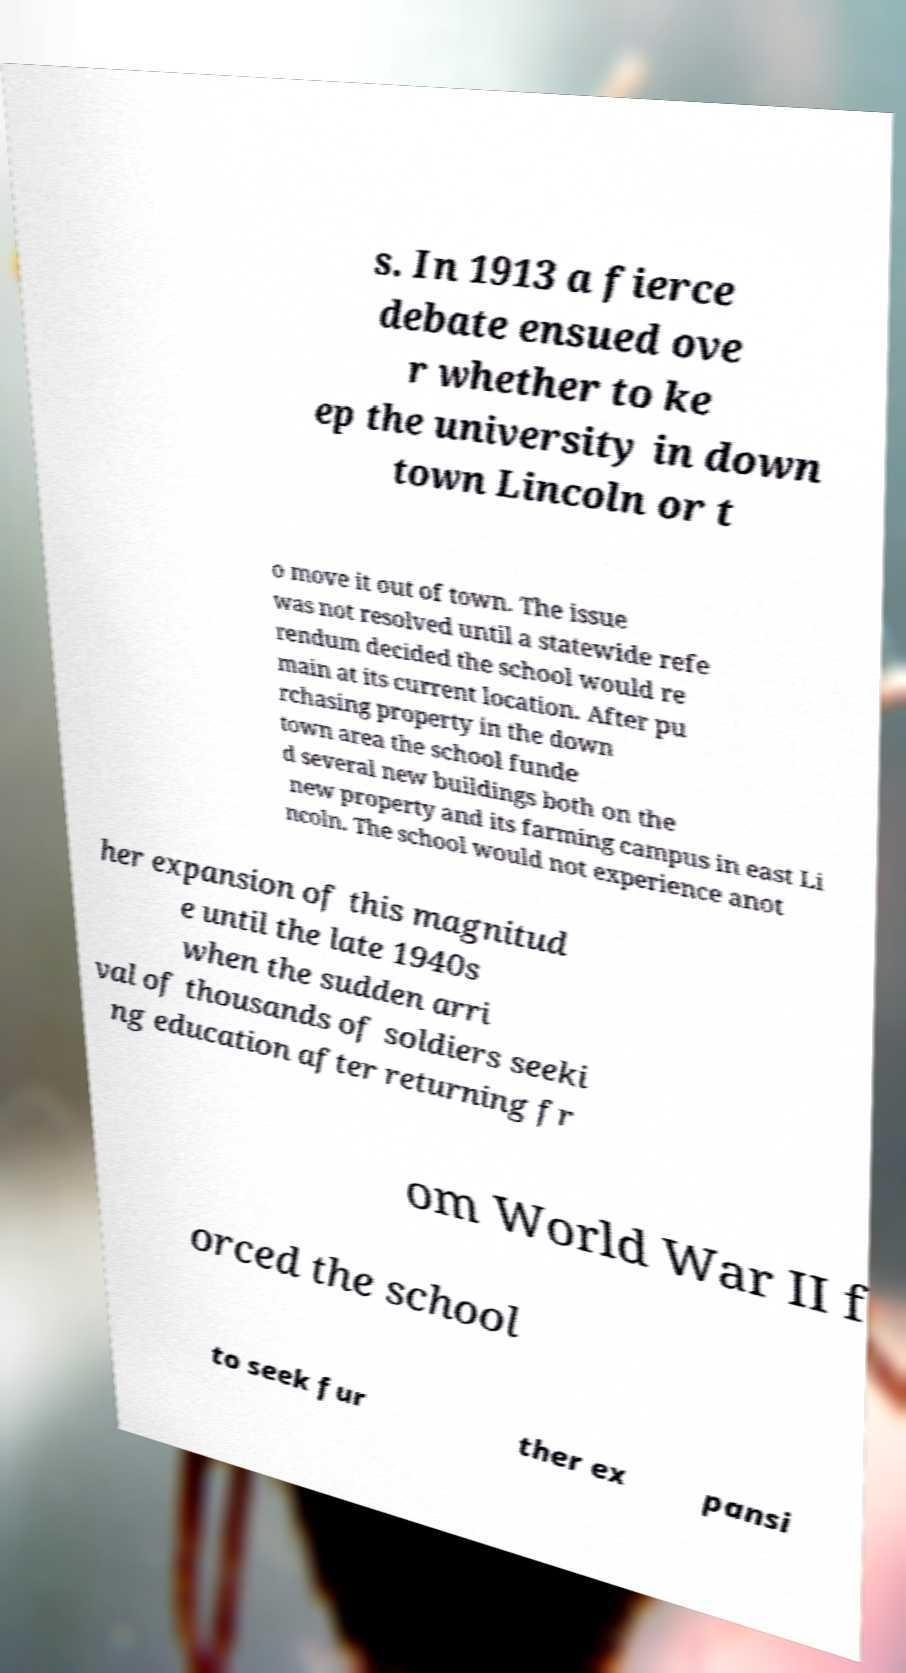Could you extract and type out the text from this image? s. In 1913 a fierce debate ensued ove r whether to ke ep the university in down town Lincoln or t o move it out of town. The issue was not resolved until a statewide refe rendum decided the school would re main at its current location. After pu rchasing property in the down town area the school funde d several new buildings both on the new property and its farming campus in east Li ncoln. The school would not experience anot her expansion of this magnitud e until the late 1940s when the sudden arri val of thousands of soldiers seeki ng education after returning fr om World War II f orced the school to seek fur ther ex pansi 